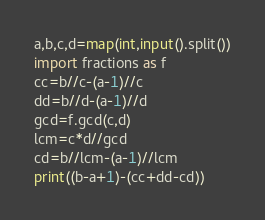<code> <loc_0><loc_0><loc_500><loc_500><_Python_>a,b,c,d=map(int,input().split())
import fractions as f
cc=b//c-(a-1)//c
dd=b//d-(a-1)//d
gcd=f.gcd(c,d)
lcm=c*d//gcd
cd=b//lcm-(a-1)//lcm
print((b-a+1)-(cc+dd-cd))</code> 